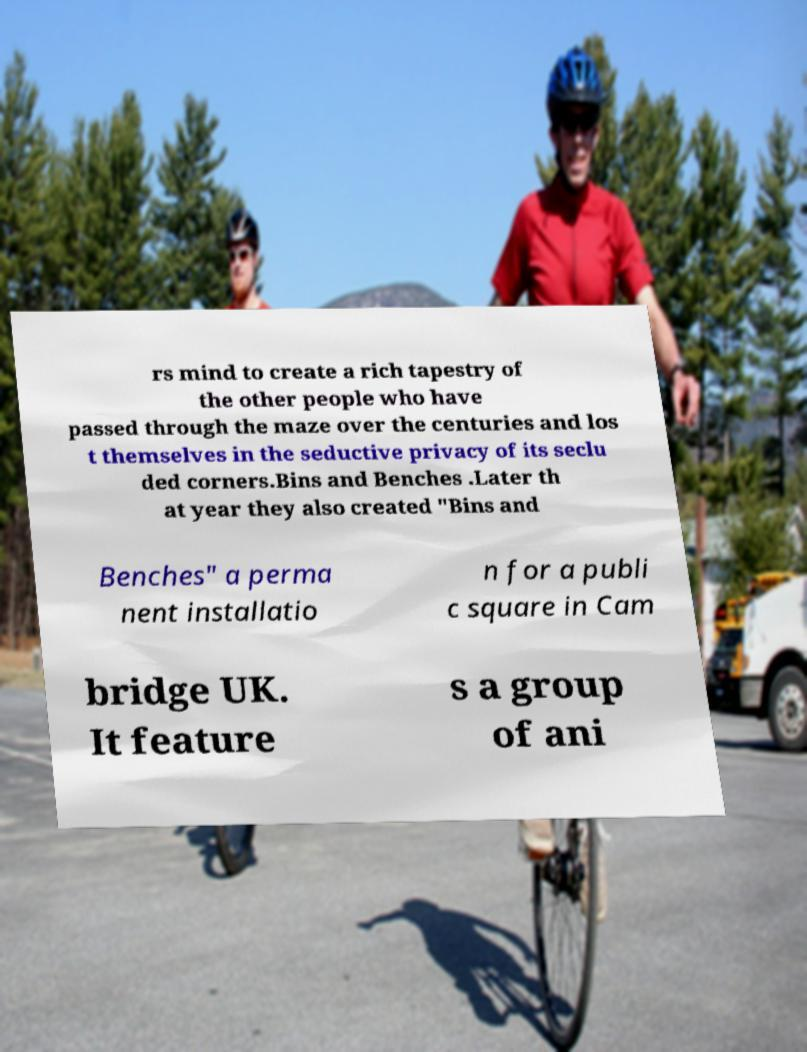Please identify and transcribe the text found in this image. rs mind to create a rich tapestry of the other people who have passed through the maze over the centuries and los t themselves in the seductive privacy of its seclu ded corners.Bins and Benches .Later th at year they also created "Bins and Benches" a perma nent installatio n for a publi c square in Cam bridge UK. It feature s a group of ani 